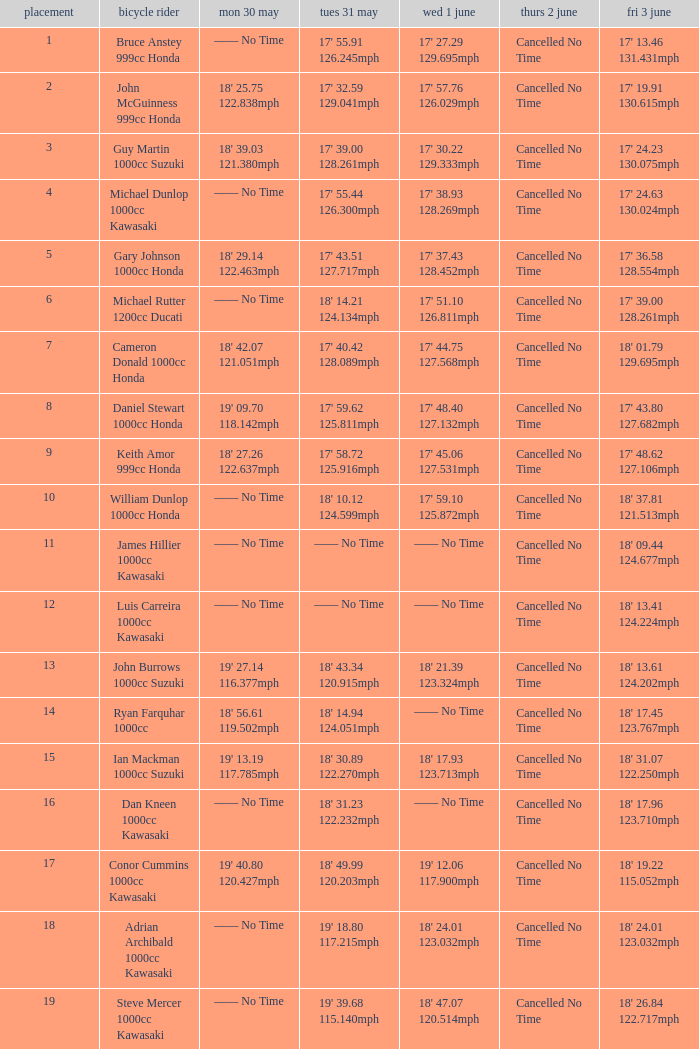What is the Fri 3 June time for the rider whose Tues 31 May time was 19' 18.80 117.215mph? 18' 24.01 123.032mph. 